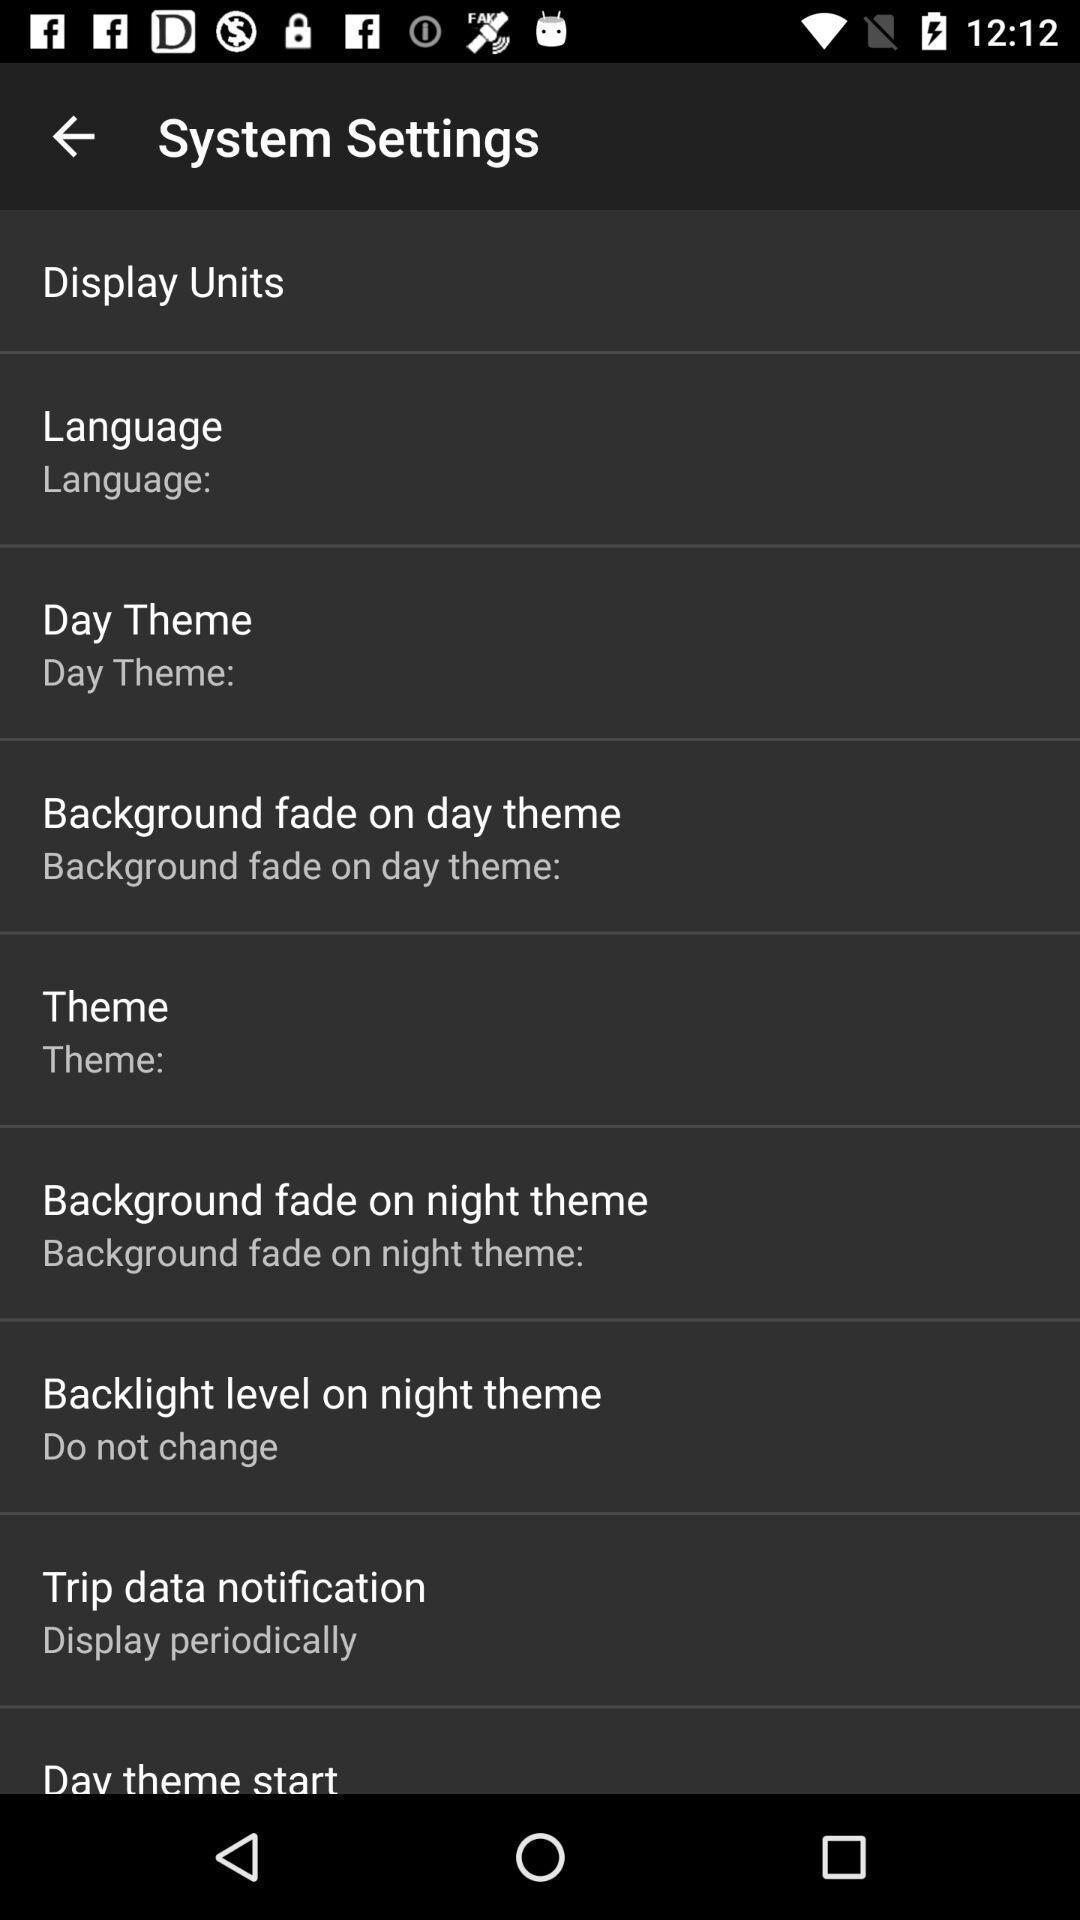Provide a detailed account of this screenshot. Page showing menu for settings. 